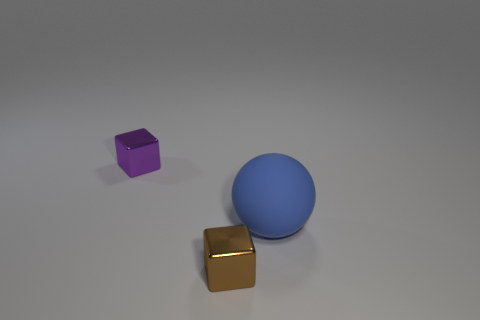Add 1 blue rubber balls. How many objects exist? 4 Subtract 2 blocks. How many blocks are left? 0 Subtract all cubes. How many objects are left? 1 Subtract all purple cubes. Subtract all blue balls. How many cubes are left? 1 Subtract all red cubes. How many purple balls are left? 0 Add 1 tiny shiny blocks. How many tiny shiny blocks are left? 3 Add 2 brown things. How many brown things exist? 3 Subtract 0 yellow cylinders. How many objects are left? 3 Subtract all small blue metal cylinders. Subtract all tiny purple objects. How many objects are left? 2 